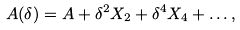<formula> <loc_0><loc_0><loc_500><loc_500>A ( \delta ) = A + \delta ^ { 2 } X _ { 2 } + \delta ^ { 4 } X _ { 4 } + \dots ,</formula> 